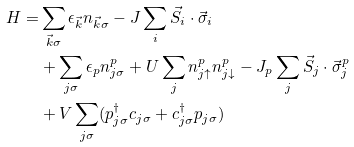Convert formula to latex. <formula><loc_0><loc_0><loc_500><loc_500>H = & \sum _ { \vec { k } \sigma } \epsilon _ { \vec { k } } n _ { \vec { k } \sigma } - J \sum _ { i } \vec { S } _ { i } \cdot \vec { \sigma } _ { i } \\ & + \sum _ { j \sigma } \epsilon _ { p } n ^ { p } _ { j \sigma } + U \sum _ { j } n ^ { p } _ { j \uparrow } n ^ { p } _ { j \downarrow } - J _ { p } \sum _ { j } \vec { S } _ { j } \cdot \vec { \sigma } ^ { p } _ { j } \\ & + V \sum _ { j \sigma } ( p _ { j \sigma } ^ { \dagger } c _ { j \sigma } + c _ { j \sigma } ^ { \dagger } p _ { j \sigma } )</formula> 